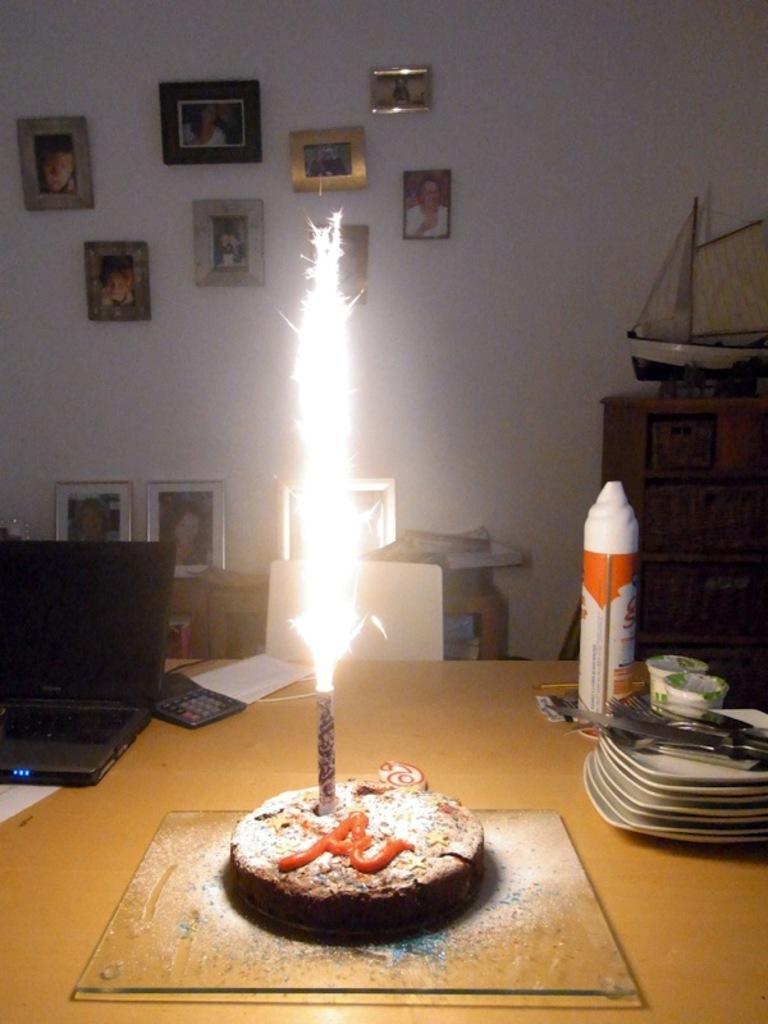In one or two sentences, can you explain what this image depicts? In this image, we can see a table, on that table there is a cake and we can see a candle on the cake, there is a black color laptop on the table, in the background we can see a wall and there are some photos on the wall. 